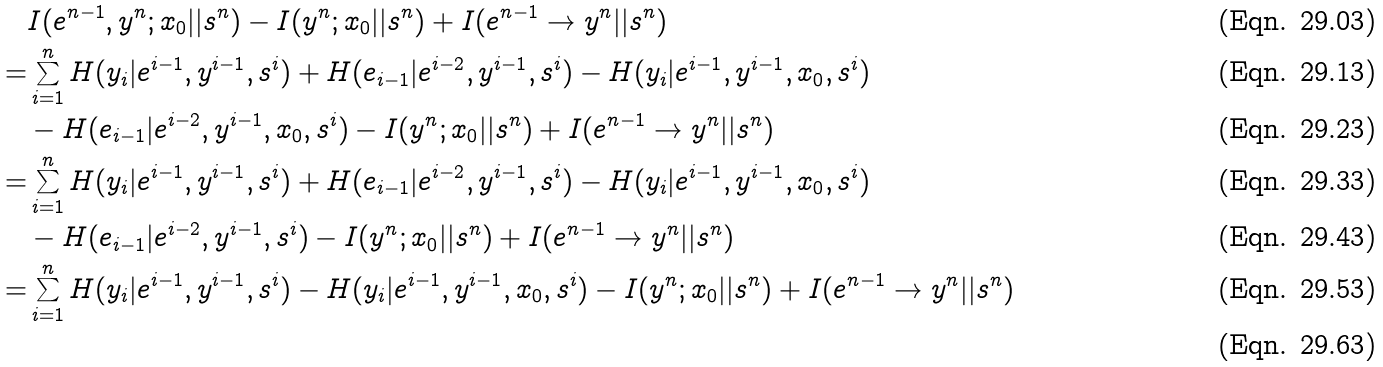<formula> <loc_0><loc_0><loc_500><loc_500>& I ( e ^ { n - 1 } , y ^ { n } ; x _ { 0 } | | s ^ { n } ) - I ( y ^ { n } ; x _ { 0 } | | s ^ { n } ) + I ( e ^ { n - 1 } \rightarrow y ^ { n } | | s ^ { n } ) \\ = & \sum _ { i = 1 } ^ { n } H ( y _ { i } | e ^ { i - 1 } , y ^ { i - 1 } , s ^ { i } ) + H ( e _ { i - 1 } | e ^ { i - 2 } , y ^ { i - 1 } , s ^ { i } ) - H ( y _ { i } | e ^ { i - 1 } , y ^ { i - 1 } , x _ { 0 } , s ^ { i } ) \\ & - H ( e _ { i - 1 } | e ^ { i - 2 } , y ^ { i - 1 } , x _ { 0 } , s ^ { i } ) - I ( y ^ { n } ; x _ { 0 } | | s ^ { n } ) + I ( e ^ { n - 1 } \rightarrow y ^ { n } | | s ^ { n } ) \\ = & \sum _ { i = 1 } ^ { n } H ( y _ { i } | e ^ { i - 1 } , y ^ { i - 1 } , s ^ { i } ) + H ( e _ { i - 1 } | e ^ { i - 2 } , y ^ { i - 1 } , s ^ { i } ) - H ( y _ { i } | e ^ { i - 1 } , y ^ { i - 1 } , x _ { 0 } , s ^ { i } ) \\ & - H ( e _ { i - 1 } | e ^ { i - 2 } , y ^ { i - 1 } , s ^ { i } ) - I ( y ^ { n } ; x _ { 0 } | | s ^ { n } ) + I ( e ^ { n - 1 } \rightarrow y ^ { n } | | s ^ { n } ) \\ = & \sum _ { i = 1 } ^ { n } H ( y _ { i } | e ^ { i - 1 } , y ^ { i - 1 } , s ^ { i } ) - H ( y _ { i } | e ^ { i - 1 } , y ^ { i - 1 } , x _ { 0 } , s ^ { i } ) - I ( y ^ { n } ; x _ { 0 } | | s ^ { n } ) + I ( e ^ { n - 1 } \rightarrow y ^ { n } | | s ^ { n } ) \\</formula> 